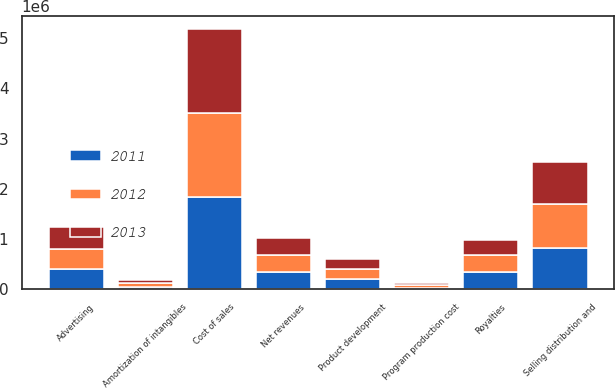Convert chart. <chart><loc_0><loc_0><loc_500><loc_500><stacked_bar_chart><ecel><fcel>Net revenues<fcel>Cost of sales<fcel>Royalties<fcel>Product development<fcel>Advertising<fcel>Amortization of intangibles<fcel>Program production cost<fcel>Selling distribution and<nl><fcel>2012<fcel>338919<fcel>1.6729e+06<fcel>338919<fcel>207591<fcel>398098<fcel>78186<fcel>47690<fcel>871679<nl><fcel>2013<fcel>338919<fcel>1.67198e+06<fcel>302066<fcel>201197<fcel>422239<fcel>50569<fcel>41800<fcel>847347<nl><fcel>2011<fcel>338919<fcel>1.83626e+06<fcel>339217<fcel>197638<fcel>413951<fcel>46647<fcel>35798<fcel>822094<nl></chart> 